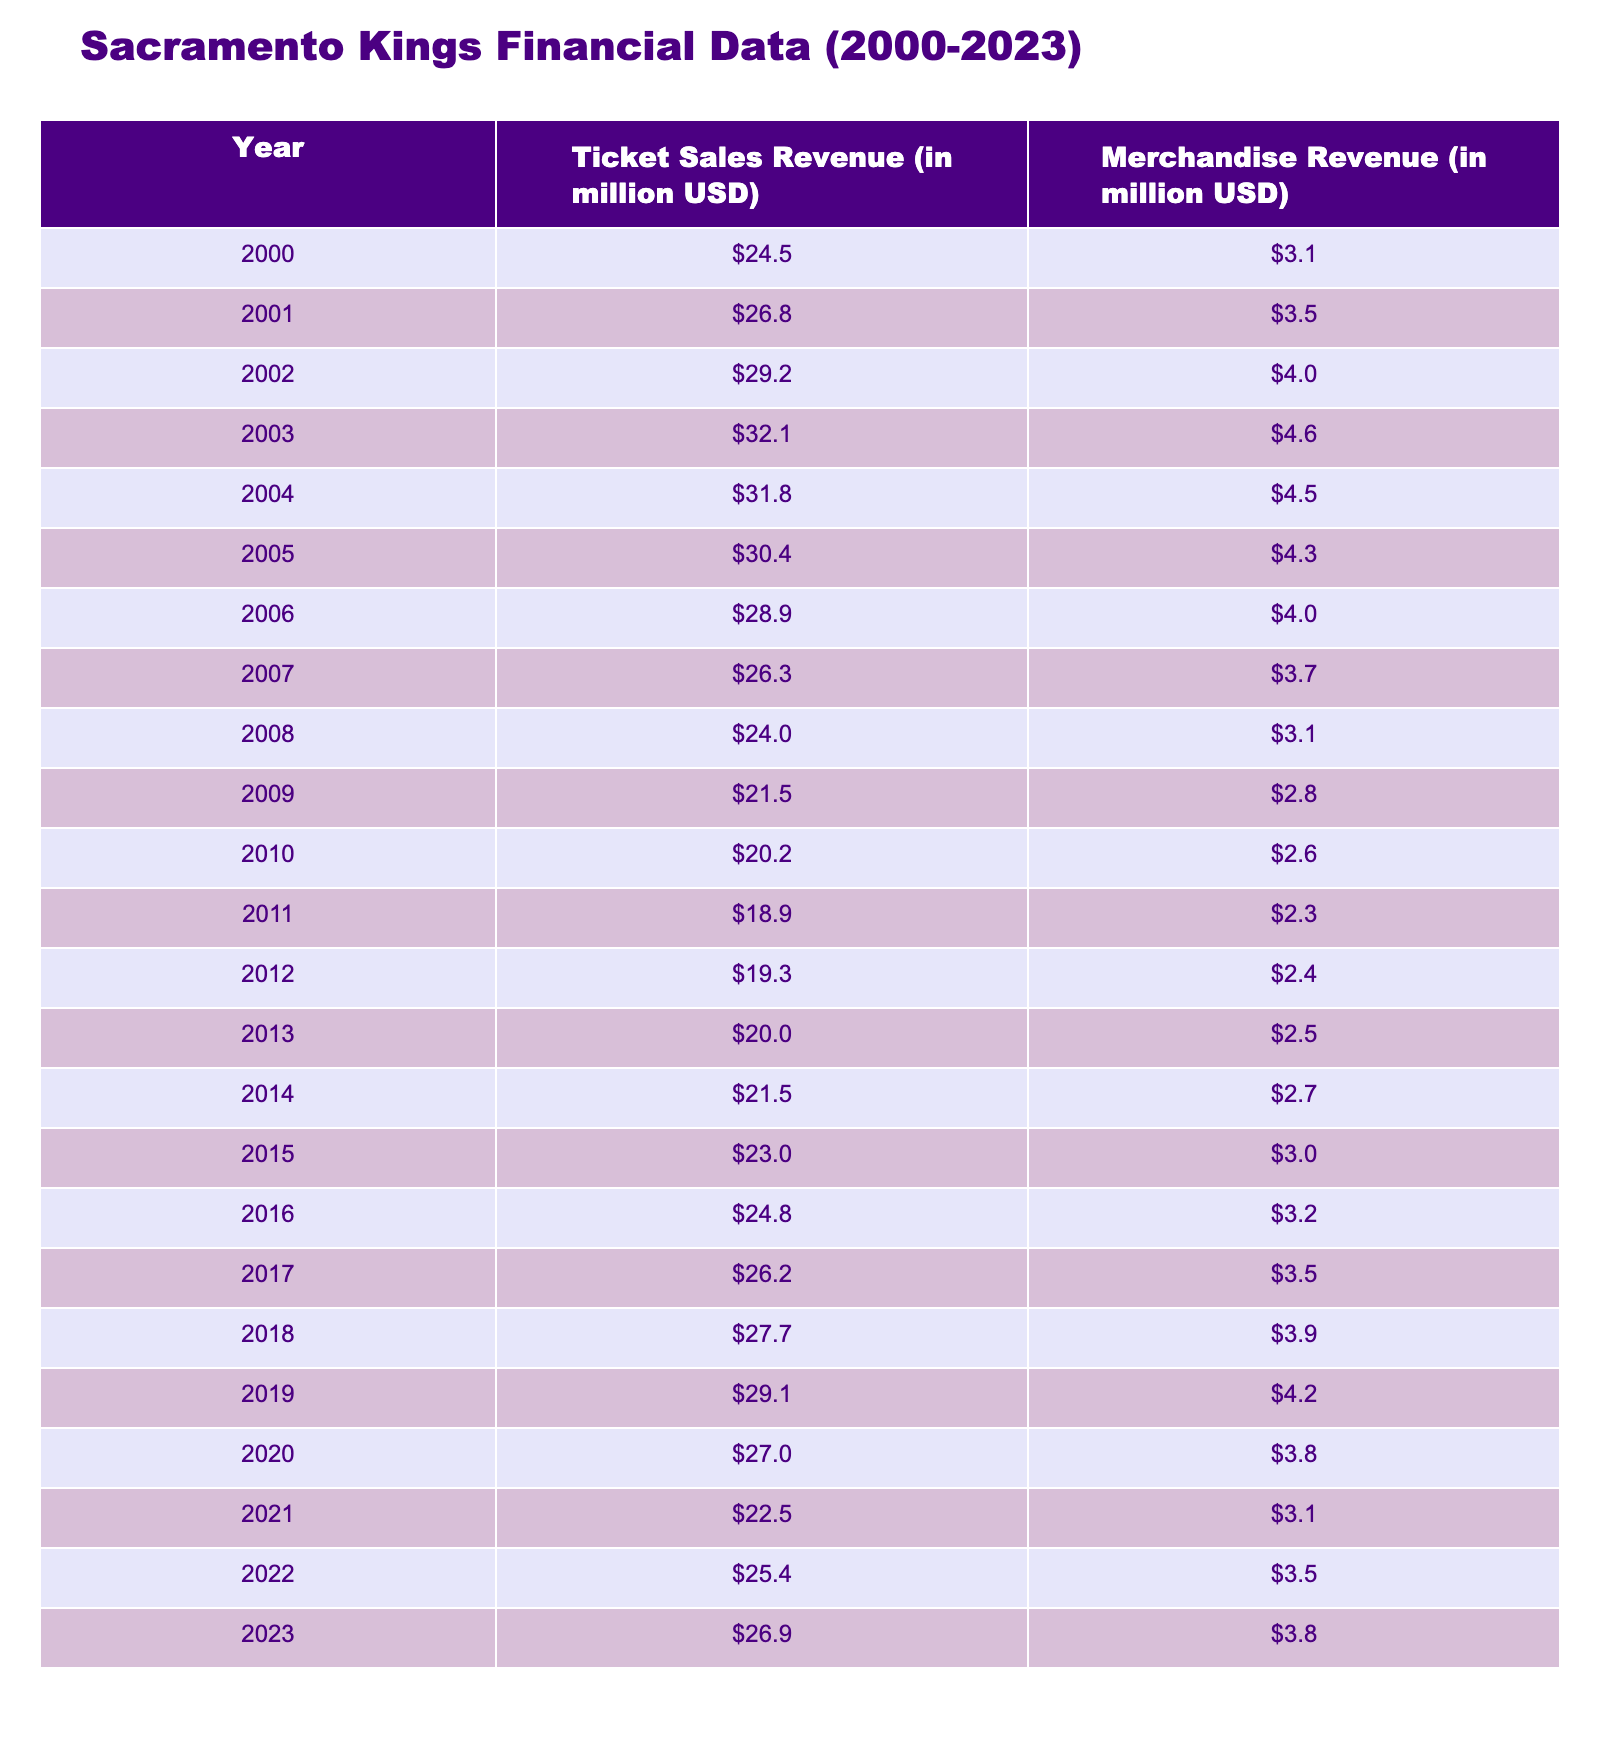What year had the highest ticket sales revenue? Looking at the Ticket Sales Revenue column, the highest value is 32.1 million USD in 2003.
Answer: 2003 What is the total merchandise revenue from 2000 to 2023? Adding all the values in the Merchandise Revenue column gives us 3.1 + 3.5 + 4.0 + 4.6 + 4.5 + 4.3 + 4.0 + 3.7 + 3.1 + 2.8 + 2.6 + 2.3 + 2.4 + 2.5 + 2.7 + 3.0 + 3.2 + 3.5 + 3.9 + 4.2 + 3.8 + 3.1 + 3.5 + 3.8 = 75.8 million USD.
Answer: 75.8 million USD Did the ticket sales revenue decrease from 2008 to 2010? From the values for 2008 (24.0 million USD), 2009 (21.5 million USD), and 2010 (20.2 million USD), it is clear that the ticket sales revenue decreased each year during this period.
Answer: Yes What was the average ticket sales revenue for the years 2016 to 2020? The ticket sales for 2016, 2017, 2018, 2019, and 2020 are 24.8, 26.2, 27.7, 29.1, and 27.0 million USD, respectively. The total is 134.8 million USD, and dividing by 5 gives an average of 26.96 million USD.
Answer: 26.96 million USD Which years saw a merchandise revenue greater than 4 million USD? The years with merchandise revenue greater than 4 million USD are 2002, 2003, 2004, 2005, 2006, 2017, 2018, and 2019. Counting these, there are 8 such years.
Answer: 8 years What was the difference in ticket sales revenue between the years with the highest and lowest values? The highest ticket sales revenue is 32.1 million USD in 2003, and the lowest is 18.9 million USD in 2011. The difference is 32.1 - 18.9 = 13.2 million USD.
Answer: 13.2 million USD Was there a year when both ticket sales and merchandise revenue increased compared to the previous year? By comparing the values year by year, 2015 to 2016 shows a ticket sales increase from 23.0 to 24.8 million USD and a merchandise increase from 3.0 to 3.2 million USD, confirming both revenues increased.
Answer: Yes What was the trend in ticket sales revenue from 2013 to 2015? Moving from 2013 (20.0 million USD) to 2014 (21.5 million USD) and then to 2015 (23.0 million USD), we see an increase each year: 20.0 to 21.5 is an increase of 1.5 million, and 21.5 to 23.0 is an increase of 1.5 million as well.
Answer: It was an increasing trend 